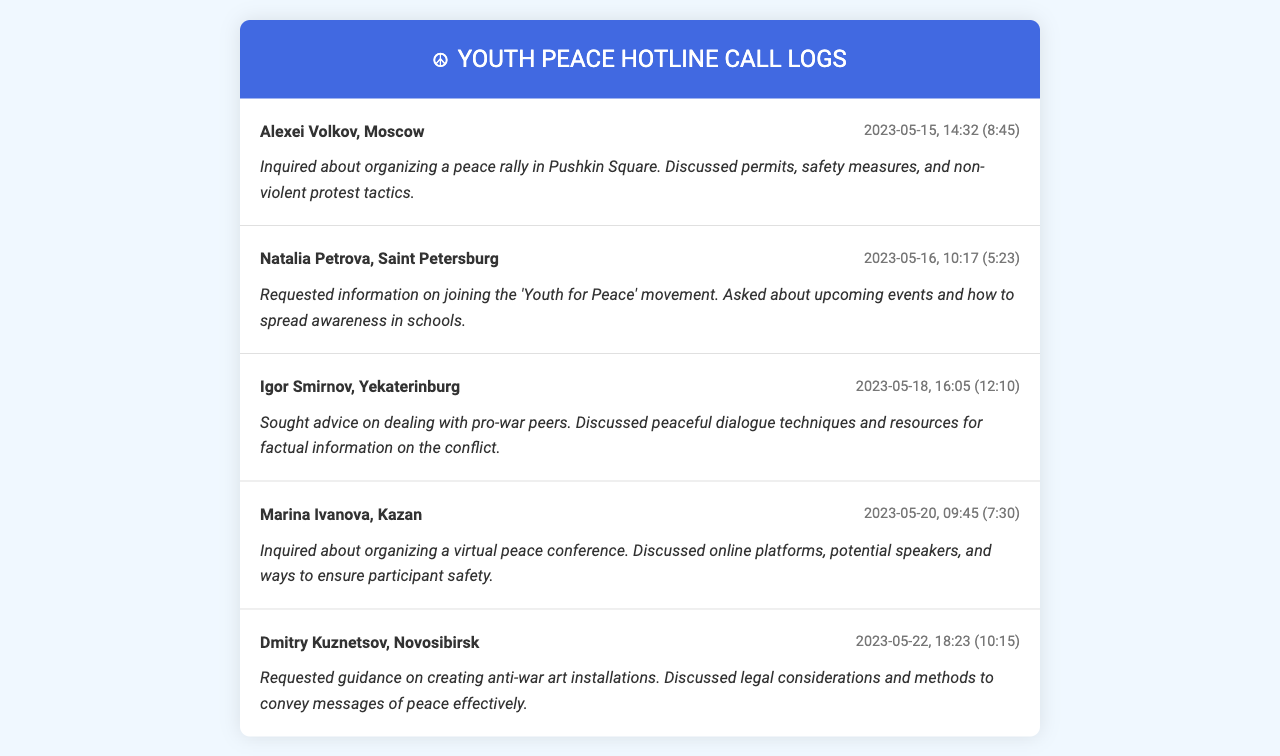What is the name of the first caller? The first caller listed in the document is Alexei Volkov from Moscow.
Answer: Alexei Volkov What city is Natalia Petrova from? Natalia Petrova, the second caller, is from Saint Petersburg.
Answer: Saint Petersburg On what date did Igor Smirnov call? Igor Smirnov's call was recorded on May 18, 2023.
Answer: 2023-05-18 How long was the call from Dmitry Kuznetsov? The call duration for Dmitry Kuznetsov was 10 minutes and 15 seconds.
Answer: 10:15 What was discussed in Marina Ivanova's call? Marina Ivanova's call focused on organizing a virtual peace conference, including aspects like online platforms and participant safety.
Answer: Organizing a virtual peace conference What topic did callers discuss regarding pro-war peers? Igor Smirnov sought advice on dealing with pro-war peers, emphasizing peaceful dialogue techniques.
Answer: Peaceful dialogue techniques What is the purpose of the 'Youth for Peace' movement? The 'Youth for Peace' movement aims to engage youth in anti-war initiatives and connect them to relevant events and awareness campaigns.
Answer: Anti-war initiatives How many minutes did Natalia Petrova's call last? Natalia Petrova's call lasted 5 minutes and 23 seconds.
Answer: 5:23 